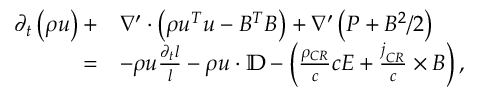<formula> <loc_0><loc_0><loc_500><loc_500>\begin{array} { r l } { \partial _ { t } \left ( \rho u \right ) + } & { \nabla ^ { \prime } \cdot \left ( \rho u ^ { T } u - B ^ { T } B \right ) + \nabla ^ { \prime } \left ( P + B ^ { 2 } / 2 \right ) } \\ { = } & { - \rho u \frac { \partial _ { t } l } { l } - \rho u \cdot \mathbb { D } - \left ( \frac { \rho _ { C R } } { c } c E + \frac { j _ { C R } } { c } \times B \right ) , } \end{array}</formula> 